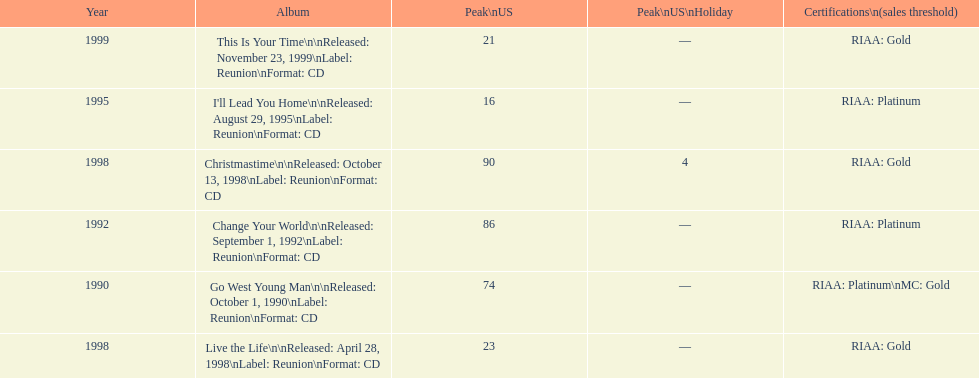Which michael w smith album had the highest ranking on the us chart? I'll Lead You Home. 